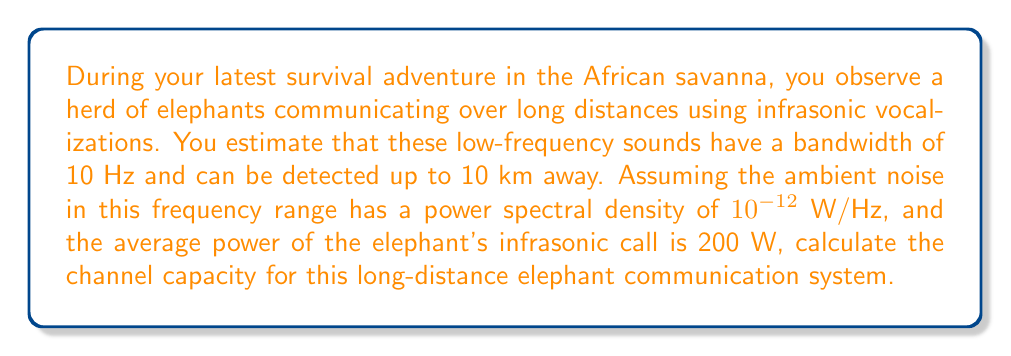What is the answer to this math problem? To solve this problem, we'll use the Shannon-Hartley theorem, which gives the channel capacity for a communication channel with additive white Gaussian noise:

$$C = B \log_2\left(1 + \frac{S}{N}\right)$$

Where:
$C$ = Channel capacity (bits/second)
$B$ = Bandwidth (Hz)
$S$ = Signal power (W)
$N$ = Noise power (W)

Given:
- Bandwidth ($B$) = 10 Hz
- Signal power ($S$) = 200 W
- Noise power spectral density = $10^{-12}$ W/Hz

Step 1: Calculate the noise power ($N$)
$N = \text{Noise power spectral density} \times \text{Bandwidth}$
$N = 10^{-12} \text{ W/Hz} \times 10 \text{ Hz} = 10^{-11} \text{ W}$

Step 2: Calculate the signal-to-noise ratio ($\frac{S}{N}$)
$$\frac{S}{N} = \frac{200 \text{ W}}{10^{-11} \text{ W}} = 2 \times 10^{13}$$

Step 3: Apply the Shannon-Hartley theorem
$$\begin{align*}
C &= B \log_2\left(1 + \frac{S}{N}\right) \\
&= 10 \text{ Hz} \times \log_2\left(1 + 2 \times 10^{13}\right) \\
&\approx 10 \text{ Hz} \times \log_2\left(2 \times 10^{13}\right) \\
&\approx 10 \text{ Hz} \times 43.8 \\
&\approx 438 \text{ bits/second}
\end{align*}$$
Answer: The channel capacity for the long-distance elephant communication system is approximately 438 bits/second. 